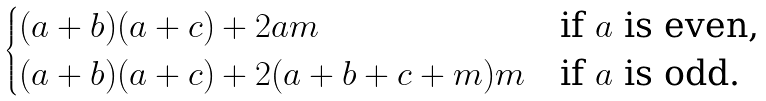Convert formula to latex. <formula><loc_0><loc_0><loc_500><loc_500>\begin{cases} ( a + b ) ( a + c ) + 2 a m & \text {if $a$ is even,} \\ ( a + b ) ( a + c ) + 2 ( a + b + c + m ) m & \text {if $a$ is odd.} \end{cases}</formula> 